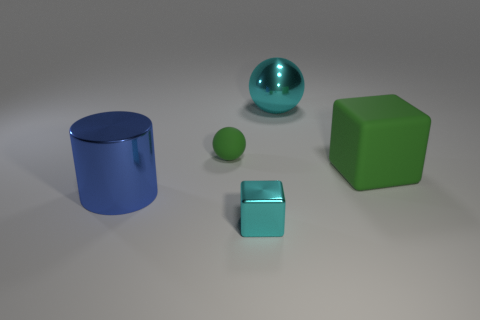Are there more blue things than tiny cyan metal spheres?
Make the answer very short. Yes. How many green objects are both behind the green cube and to the right of the big metallic sphere?
Keep it short and to the point. 0. The green matte thing on the right side of the sphere in front of the cyan metal object that is behind the tiny sphere is what shape?
Offer a terse response. Cube. Is there any other thing that has the same shape as the small cyan object?
Offer a terse response. Yes. What number of balls are either tiny things or large cyan metallic objects?
Your answer should be very brief. 2. There is a ball that is on the left side of the tiny cyan thing; is its color the same as the rubber block?
Provide a succinct answer. Yes. The cyan object behind the big metallic thing to the left of the matte thing that is to the left of the cyan metal block is made of what material?
Provide a short and direct response. Metal. Is the size of the green matte ball the same as the blue shiny cylinder?
Your answer should be compact. No. Do the rubber sphere and the large metal cylinder left of the large matte thing have the same color?
Give a very brief answer. No. What is the shape of the object that is made of the same material as the green sphere?
Provide a succinct answer. Cube. 